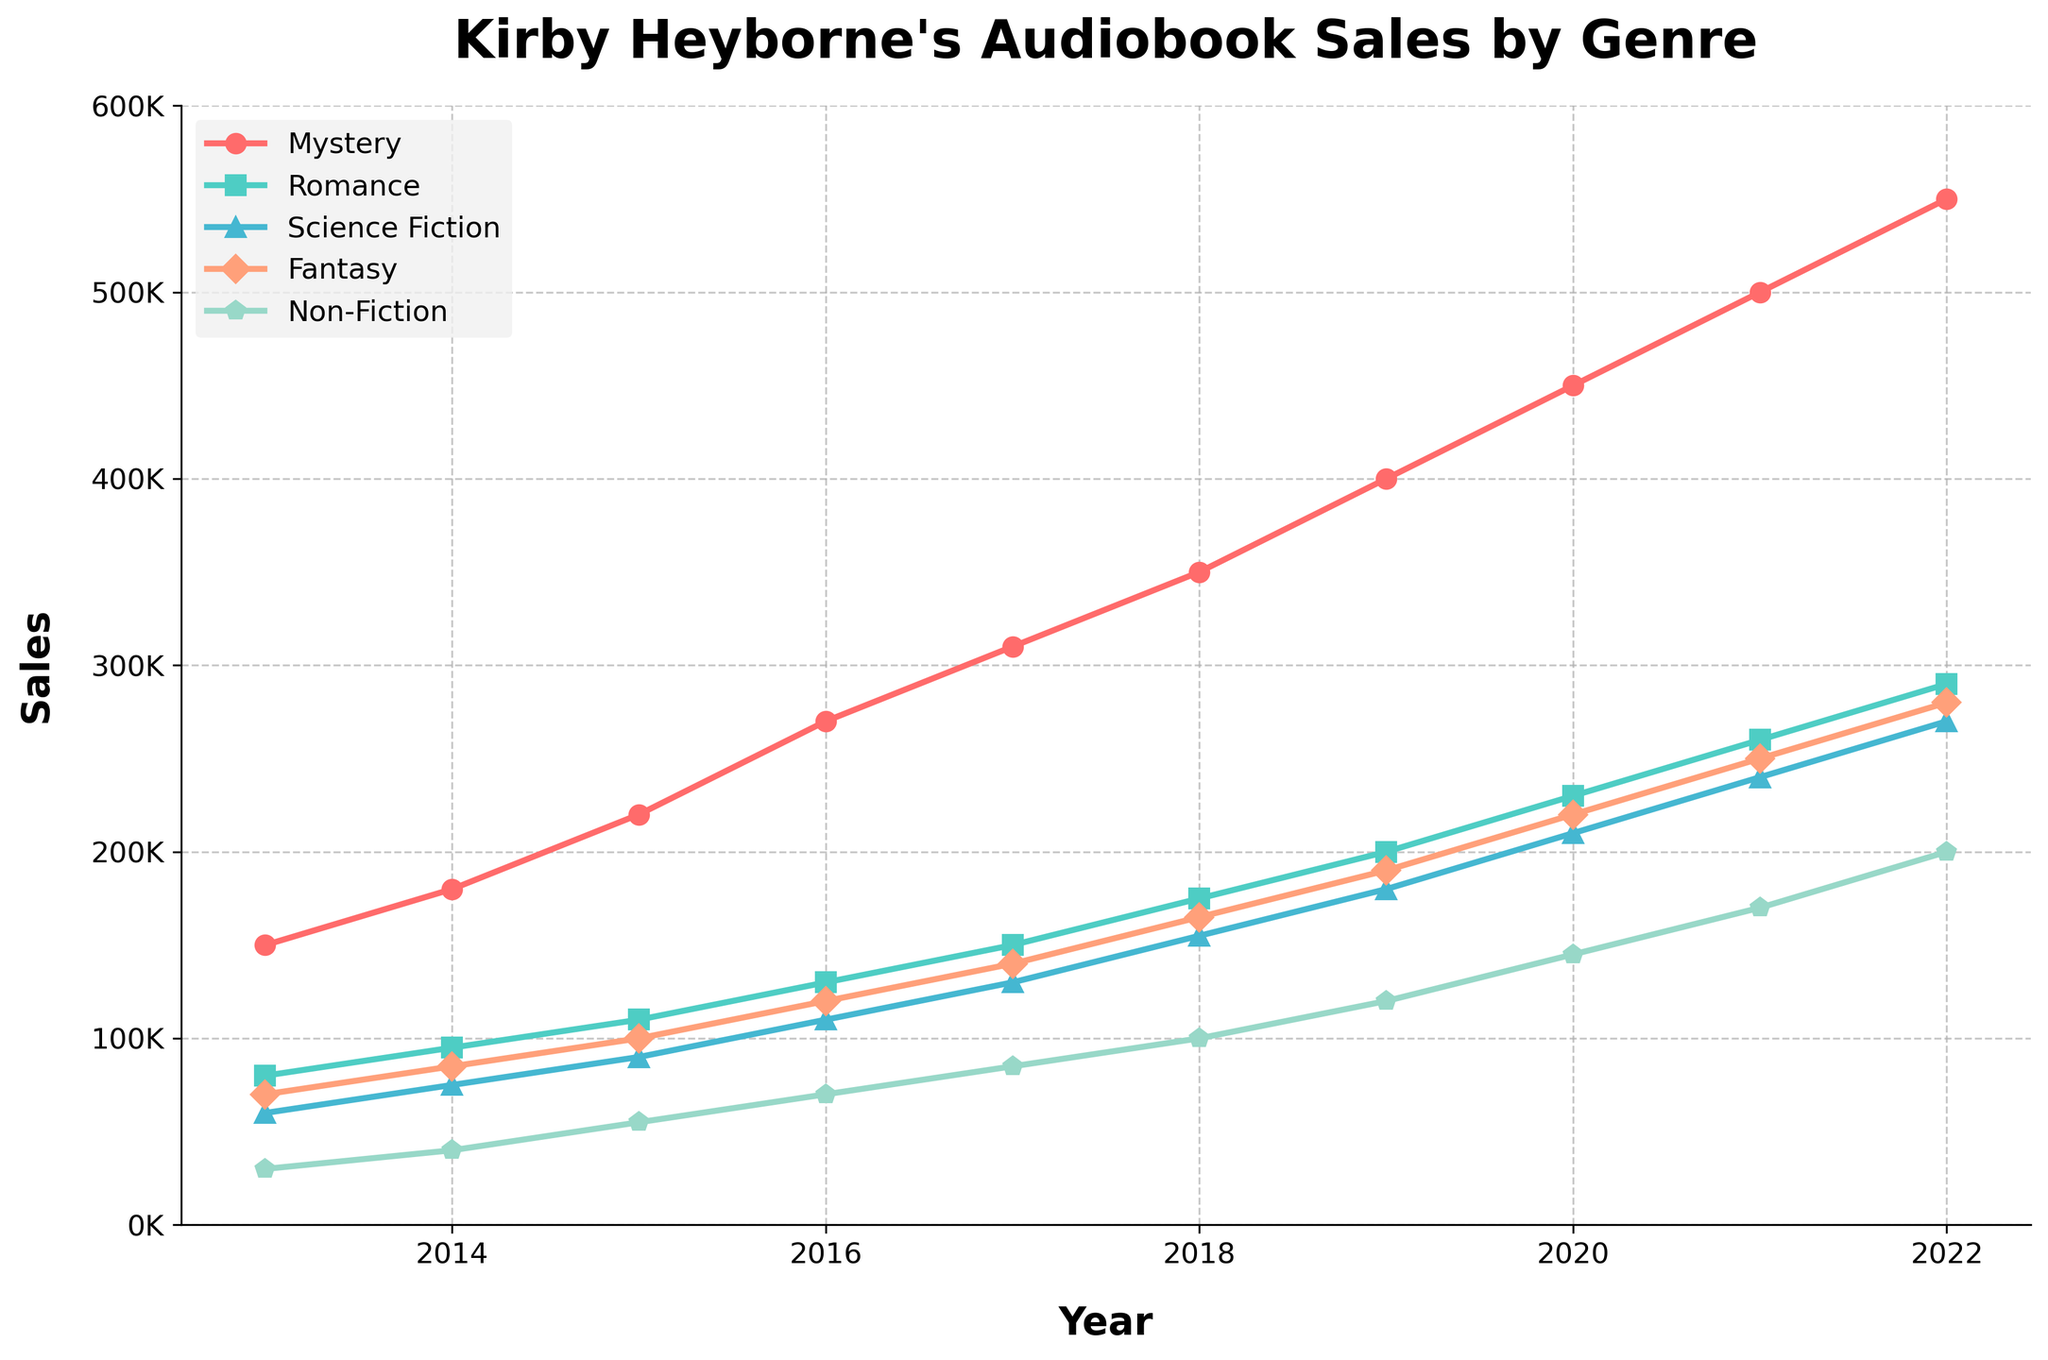What genre has the highest sales in 2022? By examining the line chart, look at the data points for the year 2022 on the Y-axis for each genre and identify which one is the highest.
Answer: Mystery Which genre had the largest increase in sales from 2013 to 2022? Compare the difference in sales for each genre between 2013 and 2022 by subtracting the 2013 sales from the 2022 sales. The genre with the largest positive difference is the one with the largest increase.
Answer: Mystery In which year did Romance sales surpass Science Fiction sales? Look at the intersection of the Romance and Science Fiction lines on the chart. Identify the earliest year where the Romance line is higher than the Science Fiction line.
Answer: 2014 What's the average sales of Fantasy audiobooks over the past decade? Add the sales numbers of Fantasy audiobooks for each year from 2013 to 2022, then divide by the number of years (10).
Answer: 164500 Between which two consecutive years did Non-Fiction see the highest growth in sales? Calculate the difference in Non-Fiction sales between each pair of consecutive years. The pair with the highest difference indicates the highest growth.
Answer: 2018-2019 How do the sales trends of Mystery and Fantasy compare from 2017 to 2020? Compare the slopes of the lines representing Mystery and Fantasy from 2017 to 2020. Both lines show an upward trend, but the Mystery line has a steeper slope, indicating a faster increase in sales.
Answer: Mystery increased faster What's the combined sales of Science Fiction and Non-Fiction in 2021? Add the sales numbers for Science Fiction and Non-Fiction for the year 2021.
Answer: 410000 Which genre had the smallest total change in sales from 2013 to 2022? Calculate the difference between the sales in 2022 and the sales in 2013 for each genre. The genre with the smallest absolute difference has the smallest total change in sales.
Answer: Non-Fiction Which genre sold more consistently (with fewer fluctuations) over the decade? Visually inspect the plot to determine which genre's line is the smoothest and experiences the fewest fluctuations.
Answer: Mystery What is the total sales of all genres combined in 2020? Sum the sales numbers of Mystery, Romance, Science Fiction, Fantasy, and Non-Fiction for the year 2020.
Answer: 1255000 